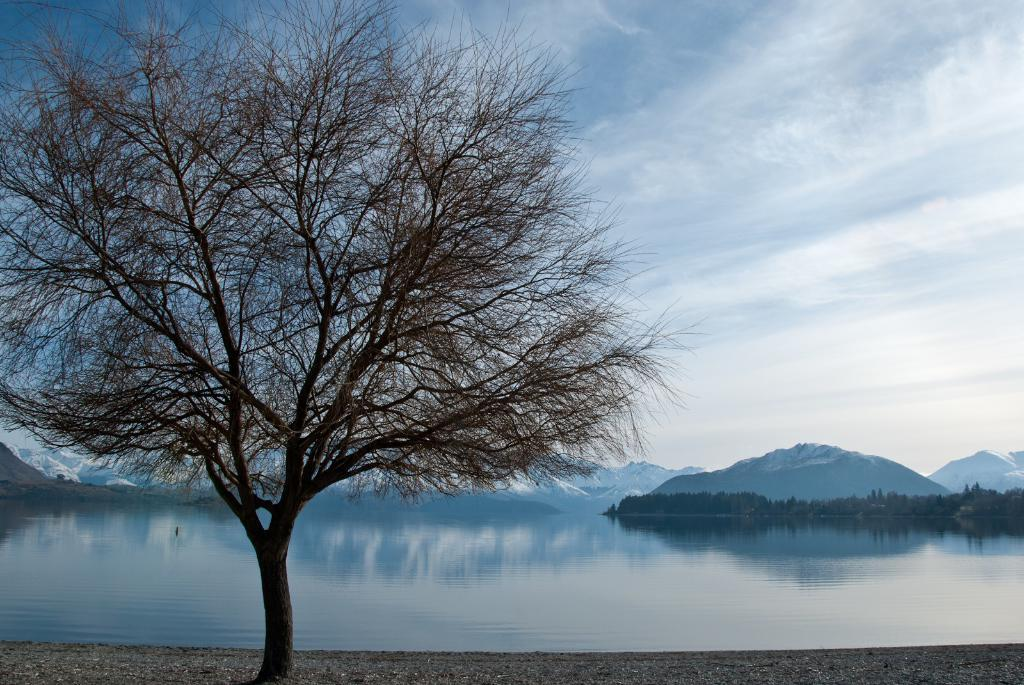What type of vegetation can be seen in the image? There is a tree in the image. What natural feature is present in the image besides the tree? There is water in the image. What geographical feature can be seen in the distance? There are mountains in the image. What is visible in the background of the image? The sky is visible in the background of the image. What can be observed in the sky? Clouds are present in the sky. What type of sack can be seen hanging from the tree in the image? There is no sack present in the image; it only features a tree, water, mountains, and clouds in the sky. What song is being sung by the clouds in the image? There is no indication in the image that the clouds are singing a song. 